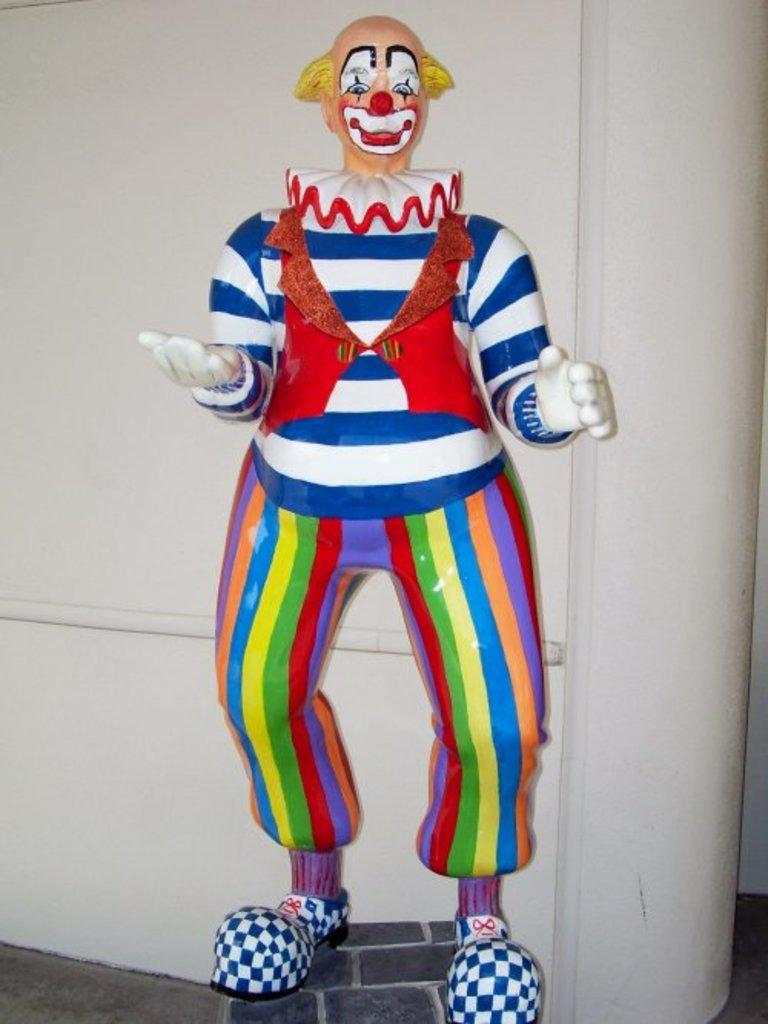What object can be seen in the image? There is a toy in the image. What can be seen behind the toy? There is a wall in the background of the image. What type of street is visible in the image? There is no street visible in the image; it only features a toy and a wall in the background. 